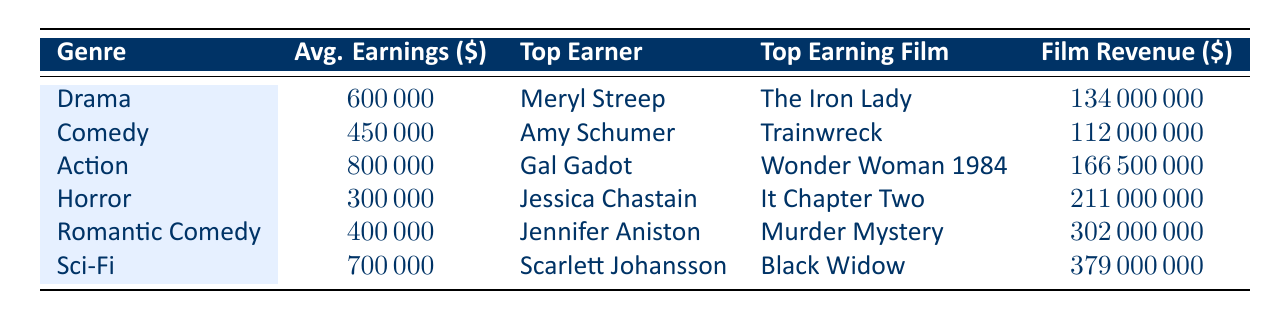What is the average earnings for female actors in the Action genre? The table indicates that the average earnings for female actors in the Action genre is listed under the "Avg. Earnings" column, which is 800000.
Answer: 800000 Who is the top earner in the Horror genre and what was her top earning film? According to the table, the top earner in the Horror genre is Jessica Chastain, and her top earning film is "It Chapter Two."
Answer: Jessica Chastain, It Chapter Two Which genre has the highest average earnings for female actors? The table shows that the Action genre has the highest average earnings at 800000, compared to other genres such as Drama, Comedy, Horror, Romantic Comedy, and Sci-Fi.
Answer: Action genre Is Jessica Chastain the top earner in the Sci-Fi genre? The table shows that Jessica Chastain is in the Horror genre and is not the top earner in Sci-Fi, where Scarlett Johansson is the top earner.
Answer: No What is the difference in average earnings between the Drama and Comedy genres? The average earnings for Drama is 600000 and for Comedy is 450000. To find the difference, we subtract the average earnings of Comedy from Drama: 600000 - 450000 = 150000.
Answer: 150000 How much revenue did the top earning film in the Romantic Comedy genre generate? The table specifies that the top earning film in the Romantic Comedy genre, "Murder Mystery," generated a revenue of 302000000.
Answer: 302000000 Which genre had the lowest average earnings for female actors? Upon reviewing the table, the Horror genre is identified with the lowest average earnings, which is 300000.
Answer: Horror What is the total revenue generated by the top earning films across all genres? The total revenue comprises the film revenues listed in the table. Summing them up: 134000000 (Drama) + 112000000 (Comedy) + 166500000 (Action) + 211000000 (Horror) + 302000000 (Romantic Comedy) + 379000000 (Sci-Fi) results in a total of 1102900000.
Answer: 1102900000 Are there any genres where the average earnings exceed 600000? Reviewing the table, we see that only the Action genre exceeds the 600000 average earnings threshold with 800000, while Drama, Comedy, Horror, Romantic Comedy, and Sci-Fi do not.
Answer: Yes 